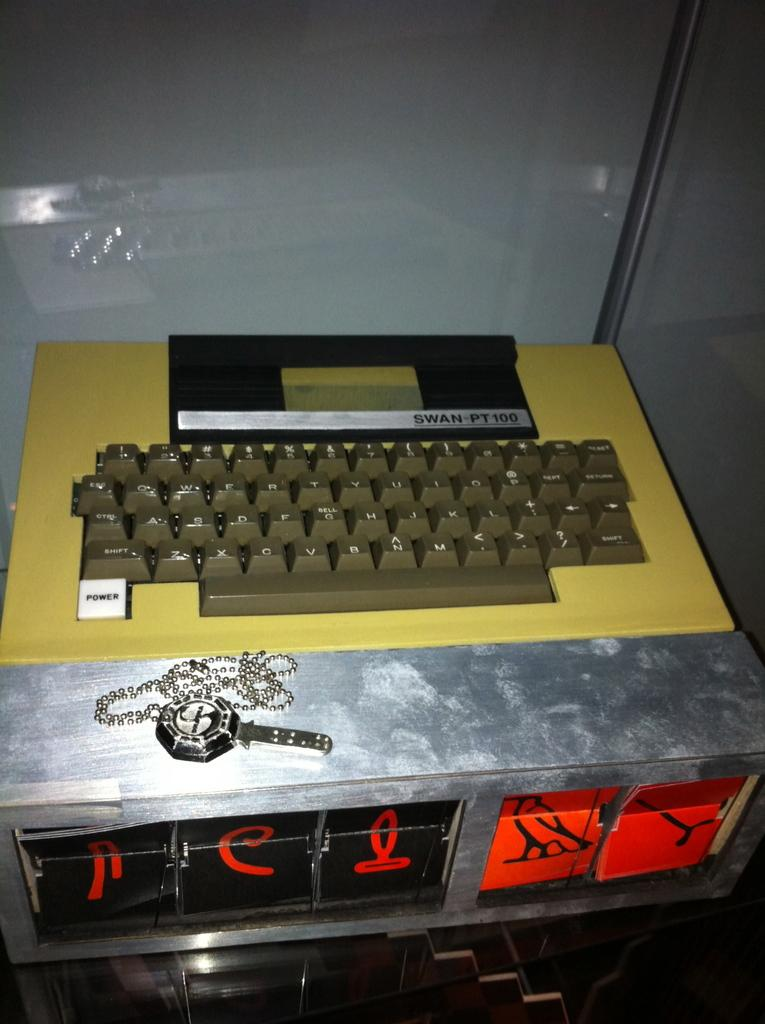<image>
Create a compact narrative representing the image presented. a keyboard in front of a label that says 'swan-pt 100' 